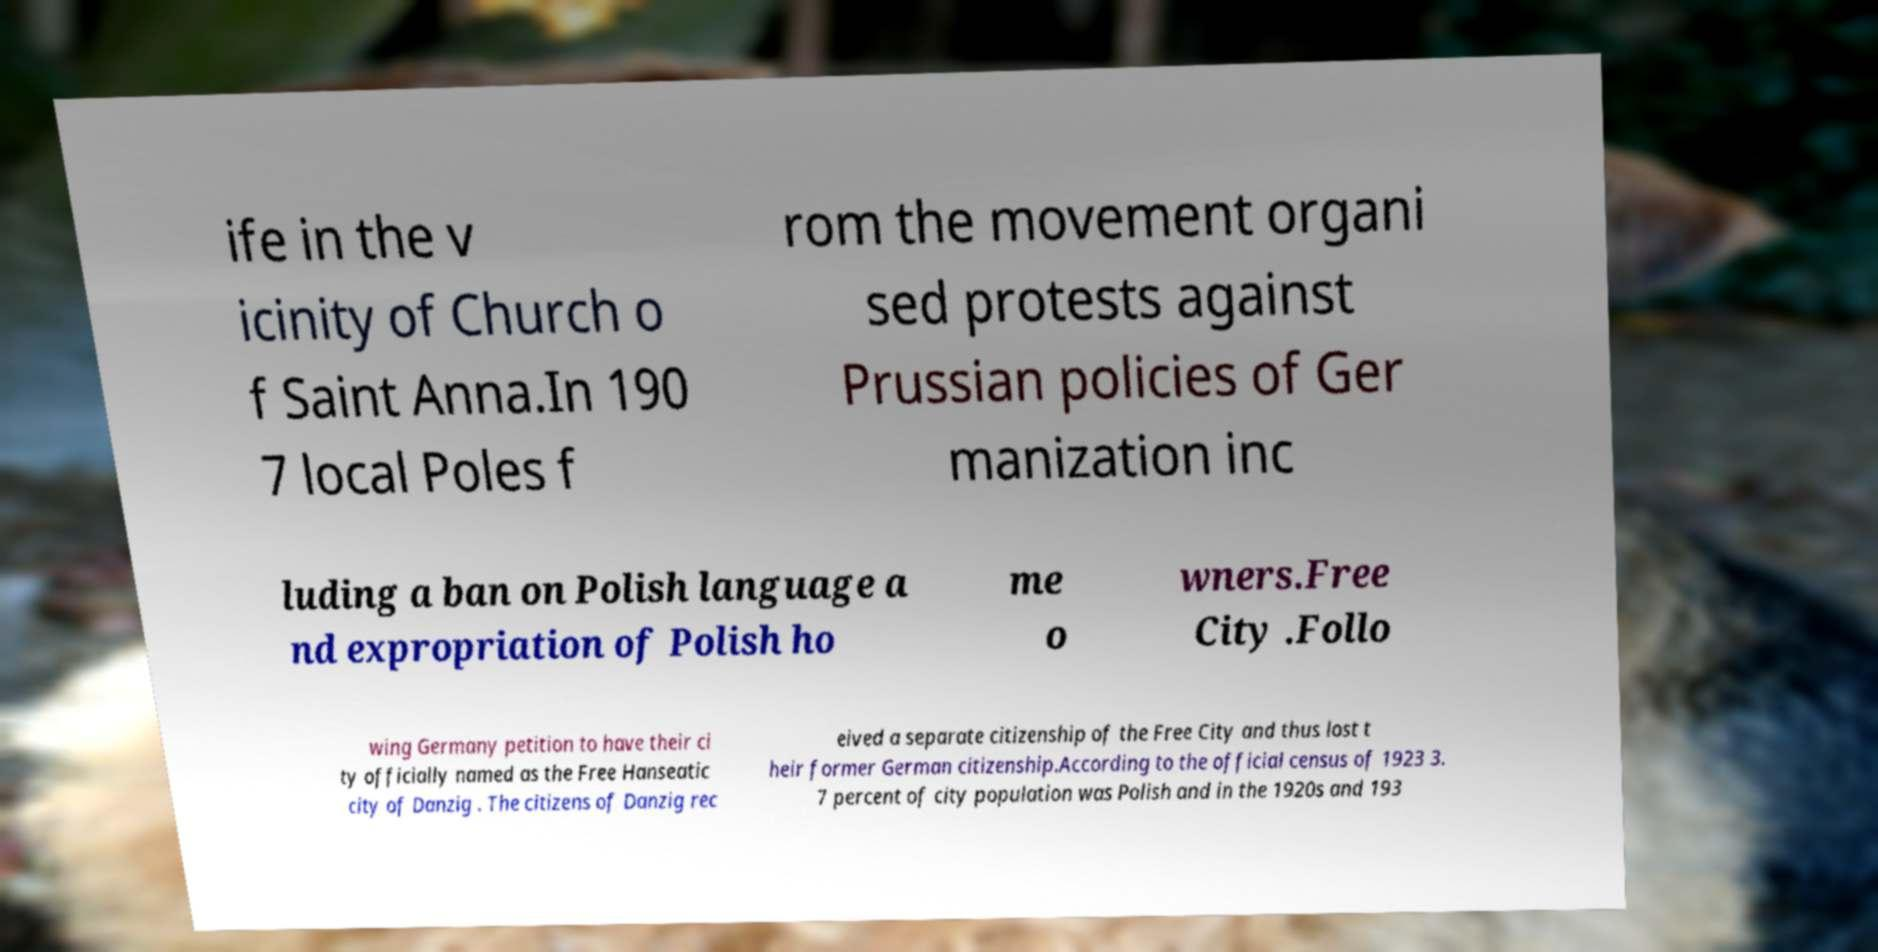Please identify and transcribe the text found in this image. ife in the v icinity of Church o f Saint Anna.In 190 7 local Poles f rom the movement organi sed protests against Prussian policies of Ger manization inc luding a ban on Polish language a nd expropriation of Polish ho me o wners.Free City .Follo wing Germany petition to have their ci ty officially named as the Free Hanseatic city of Danzig . The citizens of Danzig rec eived a separate citizenship of the Free City and thus lost t heir former German citizenship.According to the official census of 1923 3. 7 percent of city population was Polish and in the 1920s and 193 